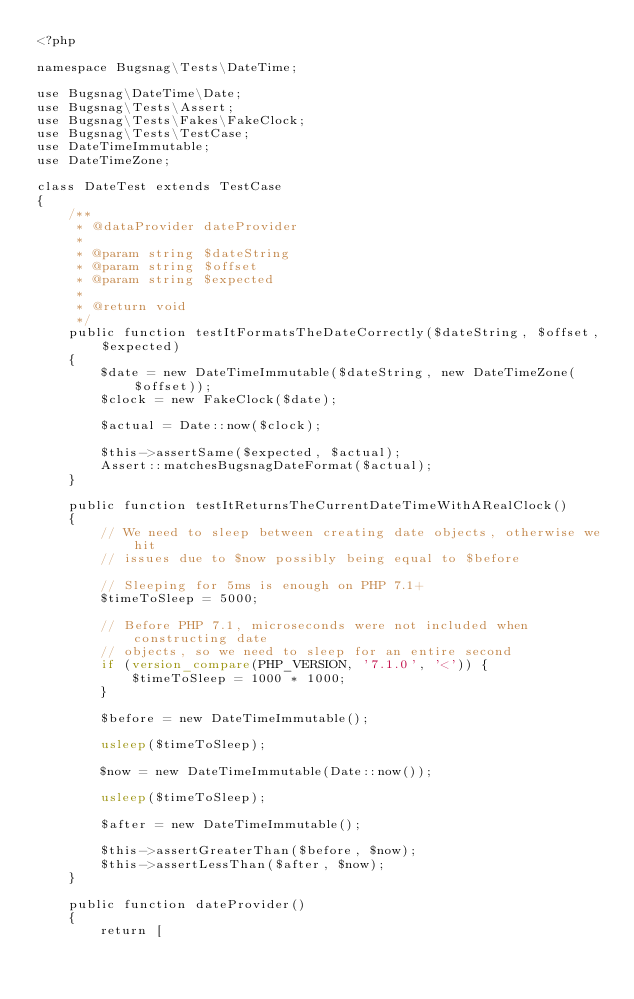Convert code to text. <code><loc_0><loc_0><loc_500><loc_500><_PHP_><?php

namespace Bugsnag\Tests\DateTime;

use Bugsnag\DateTime\Date;
use Bugsnag\Tests\Assert;
use Bugsnag\Tests\Fakes\FakeClock;
use Bugsnag\Tests\TestCase;
use DateTimeImmutable;
use DateTimeZone;

class DateTest extends TestCase
{
    /**
     * @dataProvider dateProvider
     *
     * @param string $dateString
     * @param string $offset
     * @param string $expected
     *
     * @return void
     */
    public function testItFormatsTheDateCorrectly($dateString, $offset, $expected)
    {
        $date = new DateTimeImmutable($dateString, new DateTimeZone($offset));
        $clock = new FakeClock($date);

        $actual = Date::now($clock);

        $this->assertSame($expected, $actual);
        Assert::matchesBugsnagDateFormat($actual);
    }

    public function testItReturnsTheCurrentDateTimeWithARealClock()
    {
        // We need to sleep between creating date objects, otherwise we hit
        // issues due to $now possibly being equal to $before

        // Sleeping for 5ms is enough on PHP 7.1+
        $timeToSleep = 5000;

        // Before PHP 7.1, microseconds were not included when constructing date
        // objects, so we need to sleep for an entire second
        if (version_compare(PHP_VERSION, '7.1.0', '<')) {
            $timeToSleep = 1000 * 1000;
        }

        $before = new DateTimeImmutable();

        usleep($timeToSleep);

        $now = new DateTimeImmutable(Date::now());

        usleep($timeToSleep);

        $after = new DateTimeImmutable();

        $this->assertGreaterThan($before, $now);
        $this->assertLessThan($after, $now);
    }

    public function dateProvider()
    {
        return [</code> 